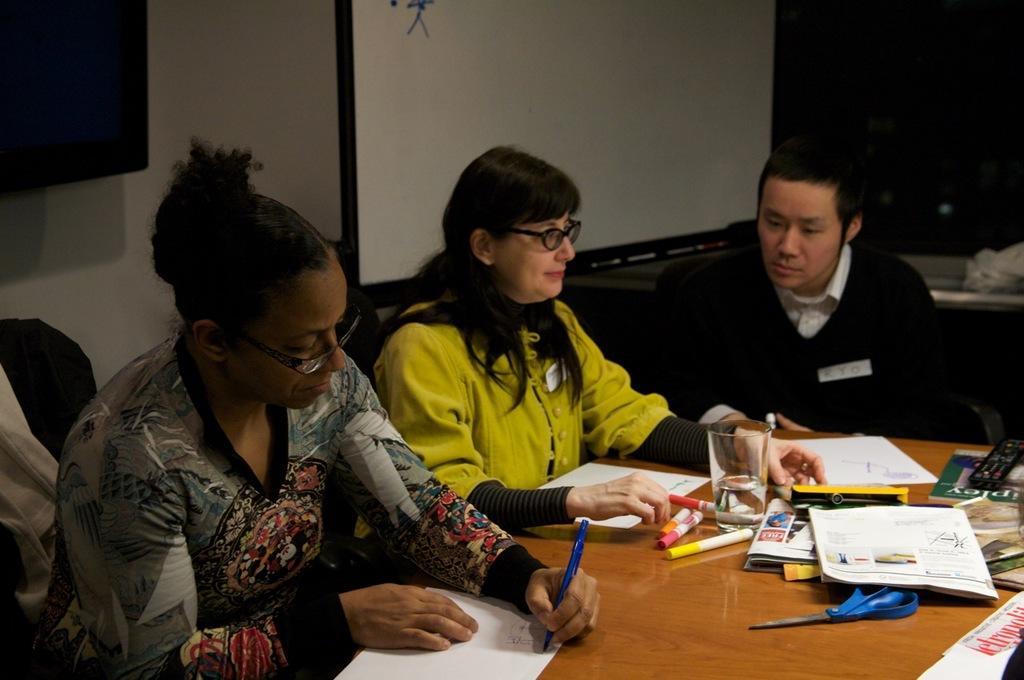Describe this image in one or two sentences. In the picture we can see a person wearing a black color dress is holding the pen and writing on the paper and is on the left side of the image, here we can see women wearing yellow color dress and spectacles is sitting on the chair near the table and we can see a person wearing a black color dress is on the right side of the image. Here we can see markers, papers, books, glasses, scissors and a few more things are placed on the wooden table. In the background, we can see the some black color object, projector screen and this part of the image is dark. 